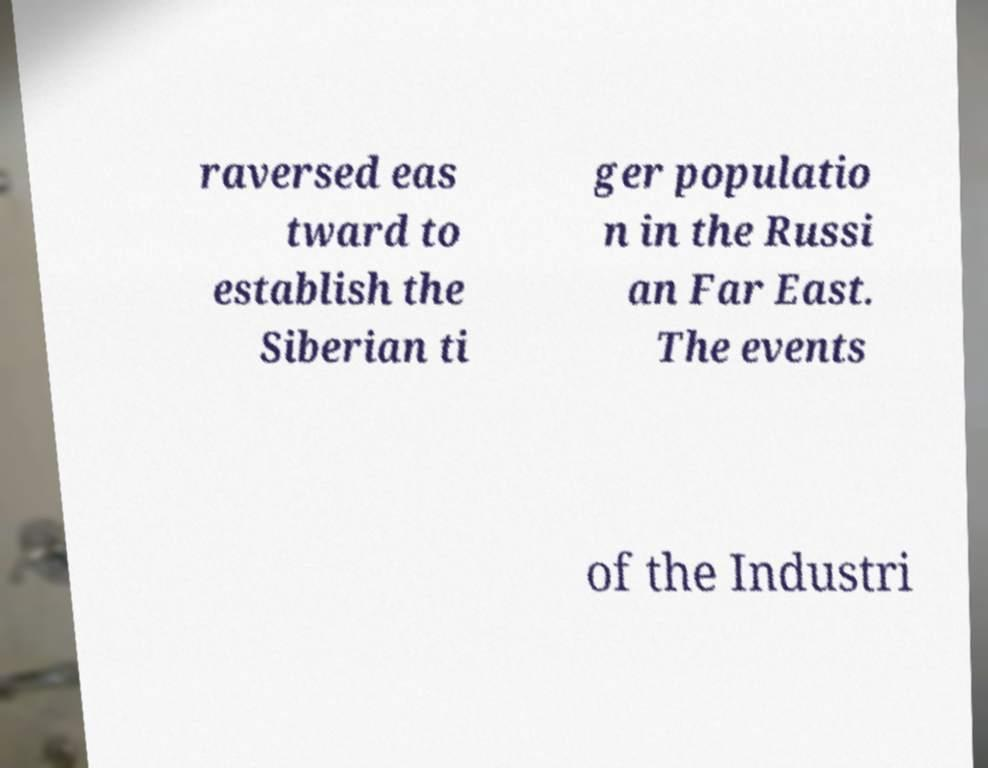I need the written content from this picture converted into text. Can you do that? raversed eas tward to establish the Siberian ti ger populatio n in the Russi an Far East. The events of the Industri 